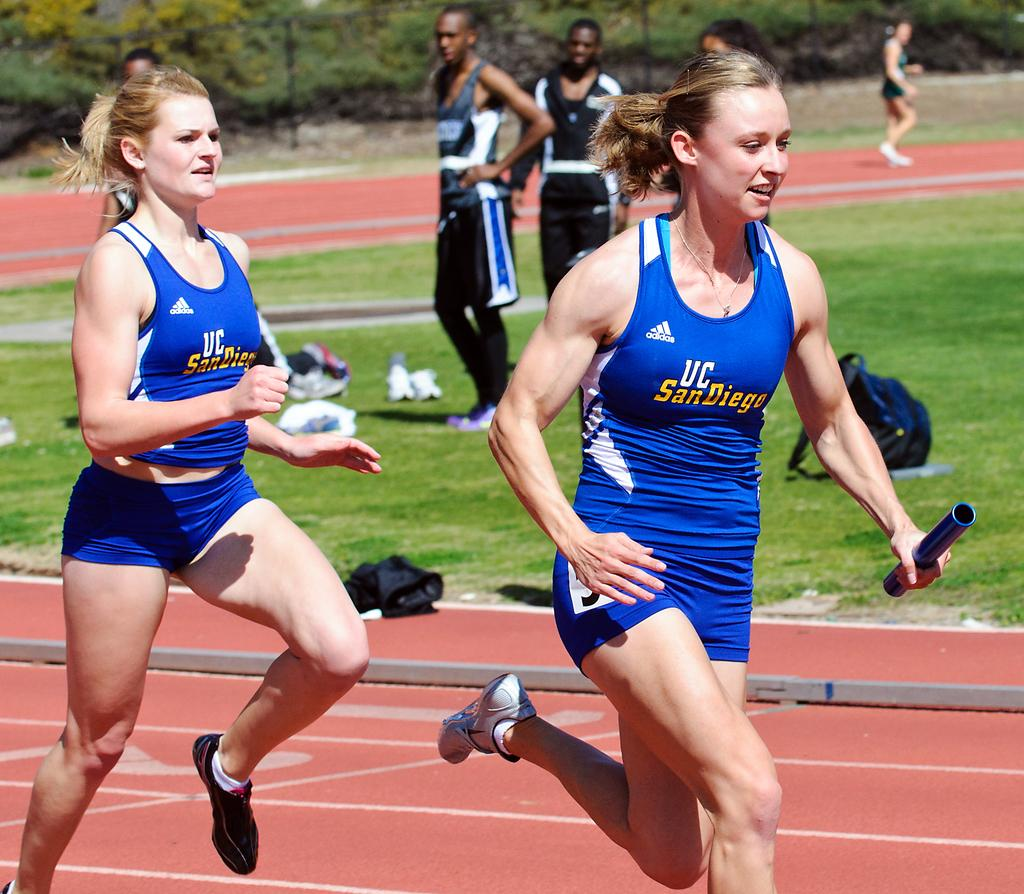<image>
Provide a brief description of the given image. UC San Diego relay race runners sprint by. 